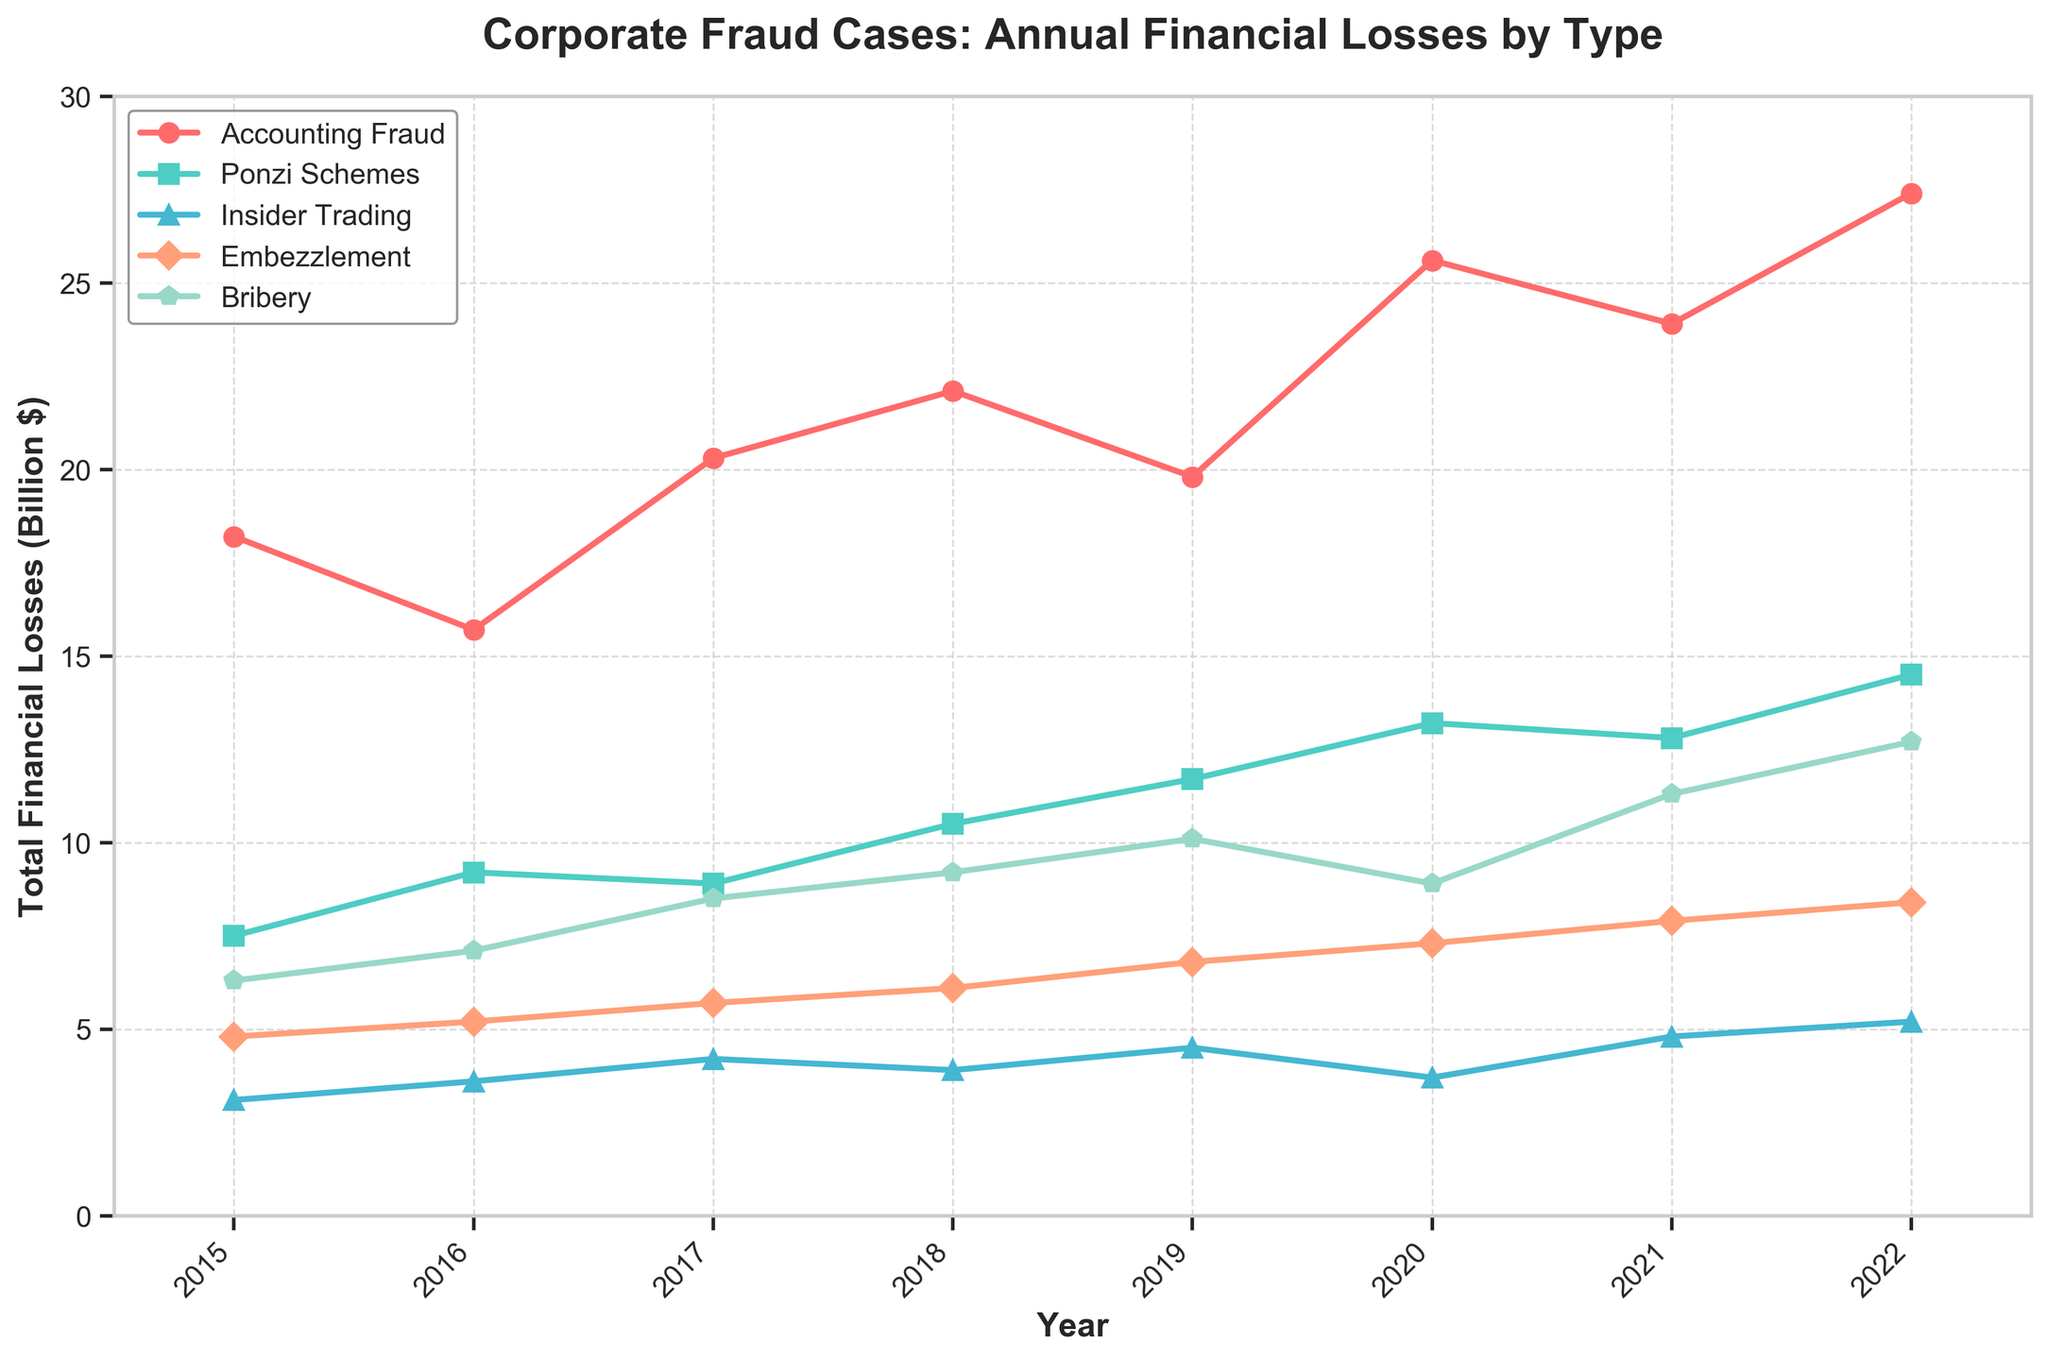Which type of fraud showed the highest total financial losses in 2022? In the figure, look at the endpoint for each type of fraud in 2022. The highest point corresponds to the type with the highest losses.
Answer: Accounting Fraud What was the total financial loss from Ponzi Schemes and Bribery combined in 2020? Find the financial losses for Ponzi Schemes and Bribery in 2020 from the respective lines. Sum the values: Ponzi Schemes (13.2) + Bribery (8.9) = 22.1
Answer: 22.1 billion $ How did the trend of Embezzlement losses change from 2018 to 2019, and then from 2019 to 2020? Compare the Embezzlement losses in 2018, 2019, and 2020 from the respective points in the chart. Note the direction (increase or decrease) of changes: 2018 to 2019 (increase from 6.1 to 6.8) and 2019 to 2020 (increase from 6.8 to 7.3)
Answer: Increased, then increased Which type of fraud experienced the largest decrease in financial losses from 2020 to 2021? Look at all the lines from 2020 to 2021 and identify which line declined the most in vertical distance.
Answer: Accounting Fraud What is the average annual financial loss from Insider Trading over the given period? Find the annual financial loss values for each year: 3.1, 3.6, 4.2, 3.9, 4.5, 3.7, 4.8, 5.2. Compute the average by summing these values and dividing by the count of values: (3.1 + 3.6 + 4.2 + 3.9 + 4.5 + 3.7 + 4.8 + 5.2) / 8 = 4. The steps are: Sum = 32, Count = 8, Average = 32 / 8
Answer: 4 billion $ Between Accounting Fraud and Bribery, which showed a more significant upward trend from 2015 to 2022? Examine the slope of the lines from 2015 to 2022 for both types. Accounting Fraud goes from 18.2 to 27.4, and Bribery goes from 6.3 to 12.7. The net increases are 27.4 - 18.2 = 9.2 for Accounting Fraud and 12.7 - 6.3 = 6.4 for Bribery.
Answer: Accounting Fraud What year exhibited the lowest financial losses from Accounting Fraud? Look along the line representing Accounting Fraud and identify the lowest point.
Answer: 2016 How do the financial losses in Ponzi Schemes in 2019 compare to those in 2020? Look at the Ponzi Schemes line for the years 2019 and 2020. Compare the heights: 2019 (11.7) and 2020 (13.2), showing an increase.
Answer: Increased What is the total combined financial loss from all types of fraud in 2021? Sum the financial loss values for each type in 2021: Accounting Fraud (23.9), Ponzi Schemes (12.8), Insider Trading (4.8), Embezzlement (7.9), Bribery (11.3). The sum is 23.9 + 12.8 + 4.8 + 7.9 + 11.3 = 60.7.
Answer: 60.7 billion $ Which type of fraud had the most consistent financial losses over the years? Examine the fluctuations in each line from 2015 to 2022. The line with the smallest changes is the most consistent.
Answer: Insider Trading 